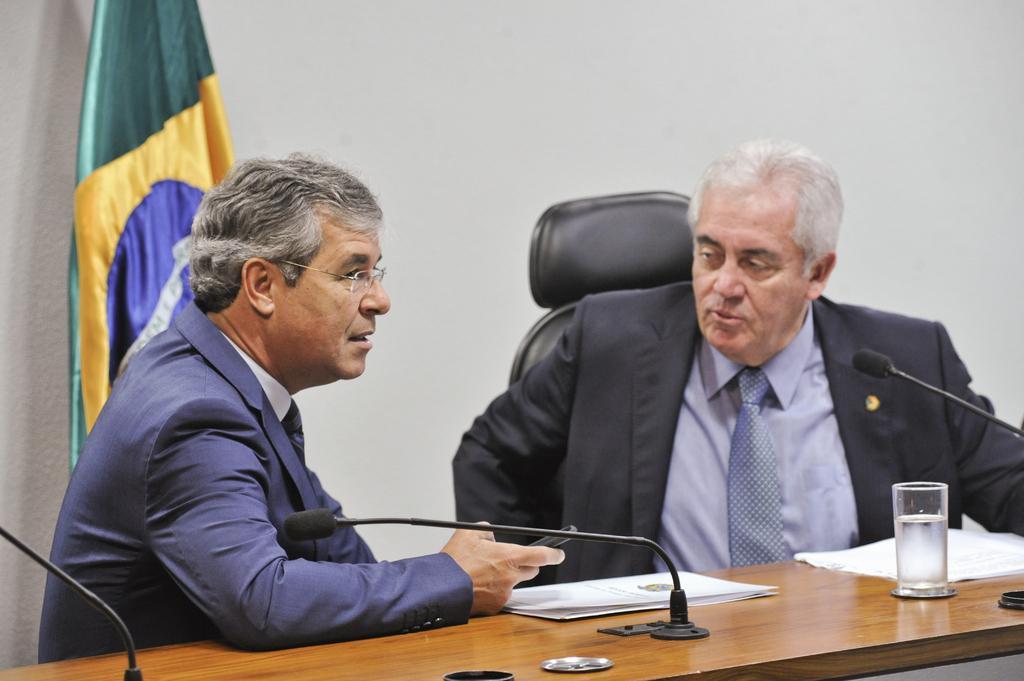Please provide a concise description of this image. In this image we can see two men sitting on the chairs. In that a man is holding a cellphone. We can also see a table in front of them containing a glass, mics with stand and some papers on it. On the backside we can see the flag and a wall. 